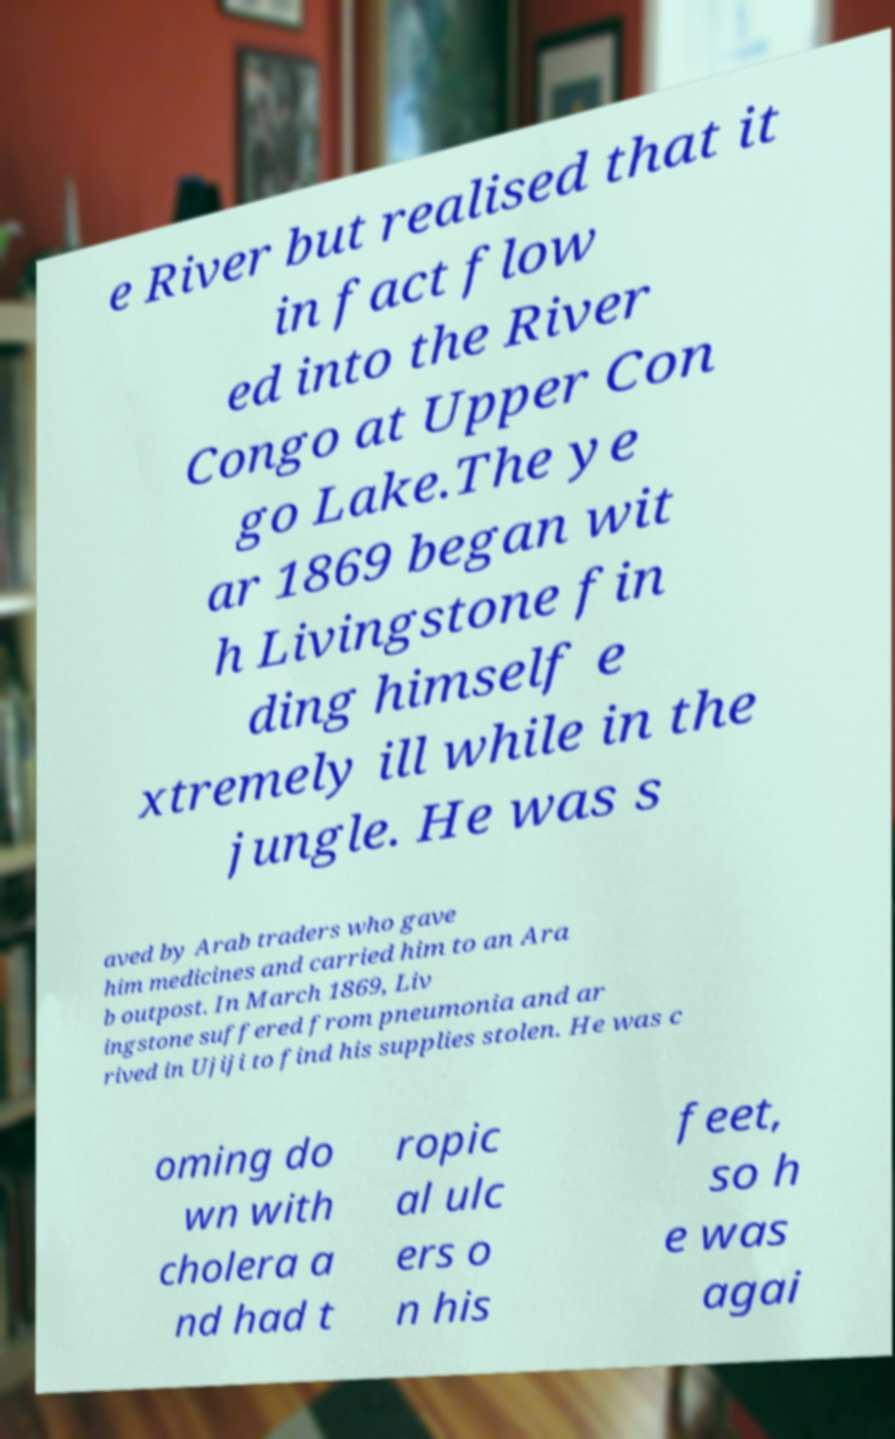Please read and relay the text visible in this image. What does it say? e River but realised that it in fact flow ed into the River Congo at Upper Con go Lake.The ye ar 1869 began wit h Livingstone fin ding himself e xtremely ill while in the jungle. He was s aved by Arab traders who gave him medicines and carried him to an Ara b outpost. In March 1869, Liv ingstone suffered from pneumonia and ar rived in Ujiji to find his supplies stolen. He was c oming do wn with cholera a nd had t ropic al ulc ers o n his feet, so h e was agai 